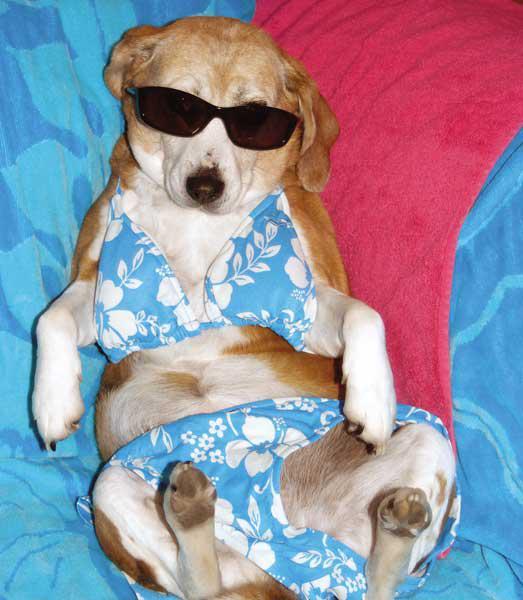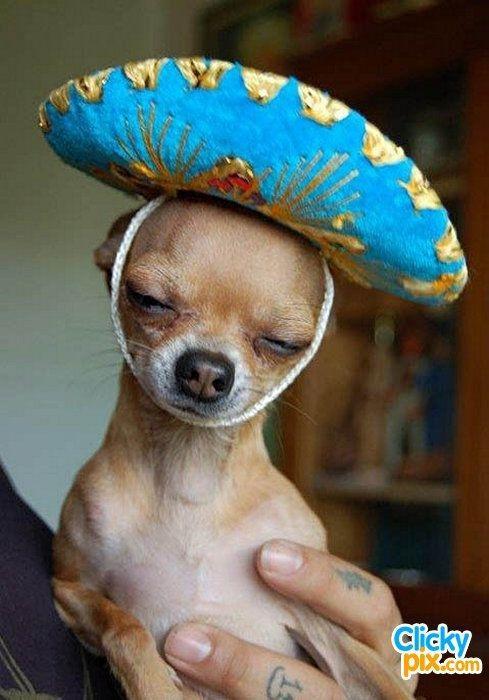The first image is the image on the left, the second image is the image on the right. Assess this claim about the two images: "The dog dressed in costume in the right hand image is photographed against a blue background.". Correct or not? Answer yes or no. No. The first image is the image on the left, the second image is the image on the right. Examine the images to the left and right. Is the description "The right image contains a dog wearing a small hat." accurate? Answer yes or no. Yes. 